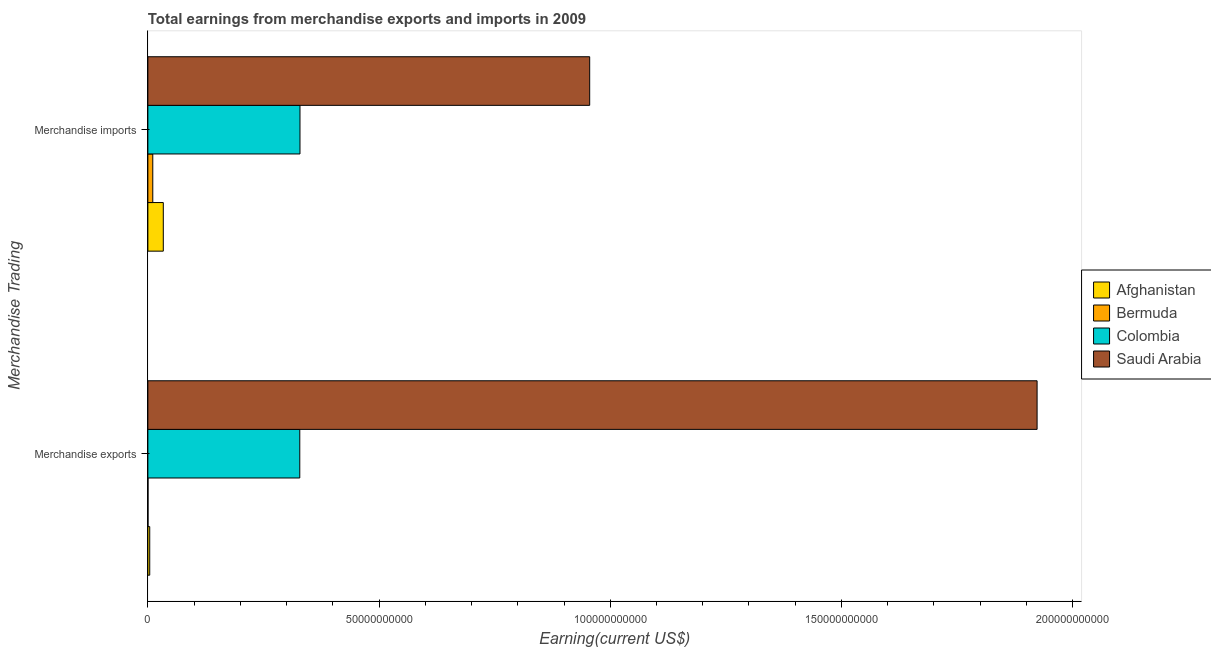How many different coloured bars are there?
Your response must be concise. 4. How many groups of bars are there?
Ensure brevity in your answer.  2. What is the earnings from merchandise exports in Colombia?
Offer a terse response. 3.29e+1. Across all countries, what is the maximum earnings from merchandise exports?
Provide a succinct answer. 1.92e+11. Across all countries, what is the minimum earnings from merchandise imports?
Ensure brevity in your answer.  1.06e+09. In which country was the earnings from merchandise imports maximum?
Your answer should be very brief. Saudi Arabia. In which country was the earnings from merchandise exports minimum?
Ensure brevity in your answer.  Bermuda. What is the total earnings from merchandise exports in the graph?
Make the answer very short. 2.26e+11. What is the difference between the earnings from merchandise exports in Bermuda and that in Colombia?
Ensure brevity in your answer.  -3.28e+1. What is the difference between the earnings from merchandise exports in Colombia and the earnings from merchandise imports in Bermuda?
Your response must be concise. 3.18e+1. What is the average earnings from merchandise imports per country?
Provide a succinct answer. 3.32e+1. What is the difference between the earnings from merchandise exports and earnings from merchandise imports in Bermuda?
Make the answer very short. -1.04e+09. What is the ratio of the earnings from merchandise exports in Saudi Arabia to that in Afghanistan?
Provide a succinct answer. 476.68. Is the earnings from merchandise imports in Colombia less than that in Afghanistan?
Give a very brief answer. No. In how many countries, is the earnings from merchandise exports greater than the average earnings from merchandise exports taken over all countries?
Give a very brief answer. 1. What does the 3rd bar from the top in Merchandise exports represents?
Keep it short and to the point. Bermuda. What does the 2nd bar from the bottom in Merchandise imports represents?
Your response must be concise. Bermuda. Are all the bars in the graph horizontal?
Ensure brevity in your answer.  Yes. How many countries are there in the graph?
Provide a short and direct response. 4. Are the values on the major ticks of X-axis written in scientific E-notation?
Provide a succinct answer. No. Does the graph contain any zero values?
Your answer should be compact. No. Does the graph contain grids?
Make the answer very short. No. What is the title of the graph?
Your answer should be compact. Total earnings from merchandise exports and imports in 2009. Does "Middle East & North Africa (developing only)" appear as one of the legend labels in the graph?
Keep it short and to the point. No. What is the label or title of the X-axis?
Your response must be concise. Earning(current US$). What is the label or title of the Y-axis?
Offer a terse response. Merchandise Trading. What is the Earning(current US$) of Afghanistan in Merchandise exports?
Offer a terse response. 4.03e+08. What is the Earning(current US$) in Bermuda in Merchandise exports?
Your answer should be very brief. 2.87e+07. What is the Earning(current US$) in Colombia in Merchandise exports?
Offer a terse response. 3.29e+1. What is the Earning(current US$) of Saudi Arabia in Merchandise exports?
Give a very brief answer. 1.92e+11. What is the Earning(current US$) in Afghanistan in Merchandise imports?
Your answer should be compact. 3.34e+09. What is the Earning(current US$) in Bermuda in Merchandise imports?
Offer a terse response. 1.06e+09. What is the Earning(current US$) of Colombia in Merchandise imports?
Make the answer very short. 3.29e+1. What is the Earning(current US$) in Saudi Arabia in Merchandise imports?
Keep it short and to the point. 9.56e+1. Across all Merchandise Trading, what is the maximum Earning(current US$) of Afghanistan?
Offer a very short reply. 3.34e+09. Across all Merchandise Trading, what is the maximum Earning(current US$) in Bermuda?
Ensure brevity in your answer.  1.06e+09. Across all Merchandise Trading, what is the maximum Earning(current US$) in Colombia?
Offer a very short reply. 3.29e+1. Across all Merchandise Trading, what is the maximum Earning(current US$) of Saudi Arabia?
Your answer should be very brief. 1.92e+11. Across all Merchandise Trading, what is the minimum Earning(current US$) of Afghanistan?
Your answer should be compact. 4.03e+08. Across all Merchandise Trading, what is the minimum Earning(current US$) in Bermuda?
Ensure brevity in your answer.  2.87e+07. Across all Merchandise Trading, what is the minimum Earning(current US$) of Colombia?
Give a very brief answer. 3.29e+1. Across all Merchandise Trading, what is the minimum Earning(current US$) in Saudi Arabia?
Your response must be concise. 9.56e+1. What is the total Earning(current US$) of Afghanistan in the graph?
Give a very brief answer. 3.74e+09. What is the total Earning(current US$) in Bermuda in the graph?
Offer a terse response. 1.09e+09. What is the total Earning(current US$) of Colombia in the graph?
Ensure brevity in your answer.  6.58e+1. What is the total Earning(current US$) of Saudi Arabia in the graph?
Your response must be concise. 2.88e+11. What is the difference between the Earning(current US$) in Afghanistan in Merchandise exports and that in Merchandise imports?
Ensure brevity in your answer.  -2.93e+09. What is the difference between the Earning(current US$) of Bermuda in Merchandise exports and that in Merchandise imports?
Provide a succinct answer. -1.04e+09. What is the difference between the Earning(current US$) of Colombia in Merchandise exports and that in Merchandise imports?
Offer a terse response. -4.47e+07. What is the difference between the Earning(current US$) in Saudi Arabia in Merchandise exports and that in Merchandise imports?
Provide a succinct answer. 9.68e+1. What is the difference between the Earning(current US$) in Afghanistan in Merchandise exports and the Earning(current US$) in Bermuda in Merchandise imports?
Your response must be concise. -6.61e+08. What is the difference between the Earning(current US$) in Afghanistan in Merchandise exports and the Earning(current US$) in Colombia in Merchandise imports?
Provide a succinct answer. -3.25e+1. What is the difference between the Earning(current US$) in Afghanistan in Merchandise exports and the Earning(current US$) in Saudi Arabia in Merchandise imports?
Keep it short and to the point. -9.51e+1. What is the difference between the Earning(current US$) in Bermuda in Merchandise exports and the Earning(current US$) in Colombia in Merchandise imports?
Provide a succinct answer. -3.29e+1. What is the difference between the Earning(current US$) in Bermuda in Merchandise exports and the Earning(current US$) in Saudi Arabia in Merchandise imports?
Ensure brevity in your answer.  -9.55e+1. What is the difference between the Earning(current US$) of Colombia in Merchandise exports and the Earning(current US$) of Saudi Arabia in Merchandise imports?
Offer a very short reply. -6.27e+1. What is the average Earning(current US$) of Afghanistan per Merchandise Trading?
Offer a very short reply. 1.87e+09. What is the average Earning(current US$) in Bermuda per Merchandise Trading?
Make the answer very short. 5.46e+08. What is the average Earning(current US$) of Colombia per Merchandise Trading?
Your answer should be compact. 3.29e+1. What is the average Earning(current US$) in Saudi Arabia per Merchandise Trading?
Your response must be concise. 1.44e+11. What is the difference between the Earning(current US$) of Afghanistan and Earning(current US$) of Bermuda in Merchandise exports?
Your response must be concise. 3.75e+08. What is the difference between the Earning(current US$) of Afghanistan and Earning(current US$) of Colombia in Merchandise exports?
Your response must be concise. -3.24e+1. What is the difference between the Earning(current US$) of Afghanistan and Earning(current US$) of Saudi Arabia in Merchandise exports?
Keep it short and to the point. -1.92e+11. What is the difference between the Earning(current US$) in Bermuda and Earning(current US$) in Colombia in Merchandise exports?
Your answer should be very brief. -3.28e+1. What is the difference between the Earning(current US$) in Bermuda and Earning(current US$) in Saudi Arabia in Merchandise exports?
Give a very brief answer. -1.92e+11. What is the difference between the Earning(current US$) of Colombia and Earning(current US$) of Saudi Arabia in Merchandise exports?
Your answer should be very brief. -1.59e+11. What is the difference between the Earning(current US$) of Afghanistan and Earning(current US$) of Bermuda in Merchandise imports?
Give a very brief answer. 2.27e+09. What is the difference between the Earning(current US$) of Afghanistan and Earning(current US$) of Colombia in Merchandise imports?
Your answer should be very brief. -2.96e+1. What is the difference between the Earning(current US$) of Afghanistan and Earning(current US$) of Saudi Arabia in Merchandise imports?
Your answer should be compact. -9.22e+1. What is the difference between the Earning(current US$) of Bermuda and Earning(current US$) of Colombia in Merchandise imports?
Offer a terse response. -3.18e+1. What is the difference between the Earning(current US$) in Bermuda and Earning(current US$) in Saudi Arabia in Merchandise imports?
Ensure brevity in your answer.  -9.45e+1. What is the difference between the Earning(current US$) of Colombia and Earning(current US$) of Saudi Arabia in Merchandise imports?
Your answer should be very brief. -6.27e+1. What is the ratio of the Earning(current US$) of Afghanistan in Merchandise exports to that in Merchandise imports?
Provide a succinct answer. 0.12. What is the ratio of the Earning(current US$) of Bermuda in Merchandise exports to that in Merchandise imports?
Keep it short and to the point. 0.03. What is the ratio of the Earning(current US$) of Colombia in Merchandise exports to that in Merchandise imports?
Your response must be concise. 1. What is the ratio of the Earning(current US$) of Saudi Arabia in Merchandise exports to that in Merchandise imports?
Keep it short and to the point. 2.01. What is the difference between the highest and the second highest Earning(current US$) of Afghanistan?
Give a very brief answer. 2.93e+09. What is the difference between the highest and the second highest Earning(current US$) of Bermuda?
Give a very brief answer. 1.04e+09. What is the difference between the highest and the second highest Earning(current US$) of Colombia?
Offer a very short reply. 4.47e+07. What is the difference between the highest and the second highest Earning(current US$) of Saudi Arabia?
Give a very brief answer. 9.68e+1. What is the difference between the highest and the lowest Earning(current US$) in Afghanistan?
Offer a very short reply. 2.93e+09. What is the difference between the highest and the lowest Earning(current US$) in Bermuda?
Provide a succinct answer. 1.04e+09. What is the difference between the highest and the lowest Earning(current US$) in Colombia?
Your response must be concise. 4.47e+07. What is the difference between the highest and the lowest Earning(current US$) in Saudi Arabia?
Your response must be concise. 9.68e+1. 